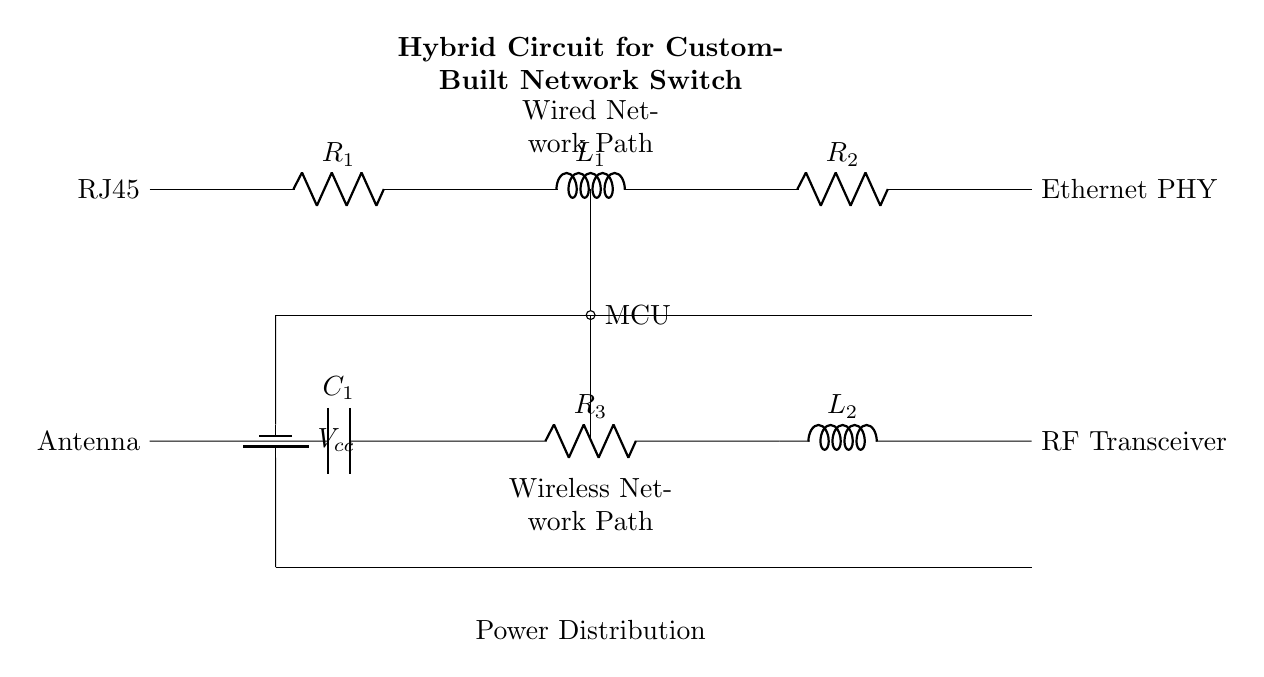What is the main purpose of this circuit? The main purpose of this circuit is to create a custom-built network switch that can handle both wired and wireless connections. It achieves this through the integration of an Ethernet PHY for wired connections and an RF transceiver with an antenna for wireless capabilities.
Answer: Custom-built network switch What type of components are used for the wired network path? The wired network path consists of resistors, inductors, and a node for an Ethernet PHY. The components used are R1, R2, and L1, L2. These components help in managing the signal flow and impedance matching for wired communication.
Answer: Resistors and inductors What role does the MCU play in this circuit? The MCU, or microcontroller, serves as the control unit that manages the operation of both the wired and wireless components. It processes data and controls the switching between the two network paths.
Answer: Control unit What is the function of the RF transceiver in this circuit? The RF transceiver's role is to facilitate wireless communication. It modulates and demodulates signals sent and received through the antenna, enabling the network switch to connect with wireless devices.
Answer: Facilitate wireless communication How are the wired and wireless paths powered? Both the wired and wireless paths are powered by a common power supply labeled Vcc, which distributes voltage through the circuit to both paths ensuring proper operation of the components.
Answer: Common power supply What is the role of the capacitor in the wireless section? The capacitor, labeled as C1, is typically used to filter or stabilize the voltage and smooth out any fluctuations or noise in the signal, thereby improving the performance of the RF transceiver.
Answer: Filter or stabilize the voltage 